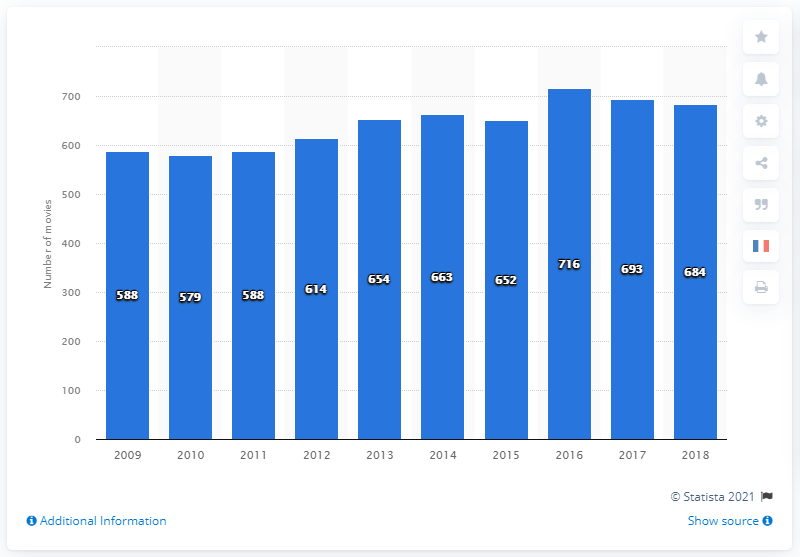Identify some key points in this picture. In 2018, a total of 684 new movies were released in France. Since 2009, the number of new movies released in France has increased. 